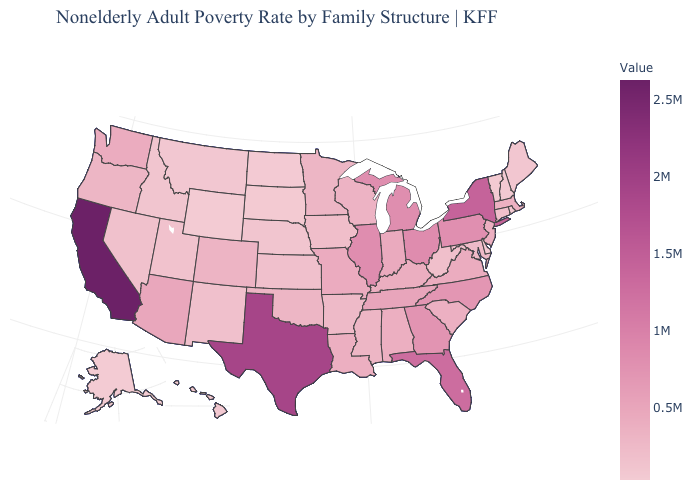Does Wyoming have the lowest value in the USA?
Give a very brief answer. Yes. Does Wyoming have the lowest value in the West?
Write a very short answer. Yes. Does Wyoming have the lowest value in the USA?
Write a very short answer. Yes. Which states have the lowest value in the USA?
Be succinct. Wyoming. Does Illinois have a higher value than New York?
Quick response, please. No. Does Wyoming have the lowest value in the USA?
Answer briefly. Yes. 